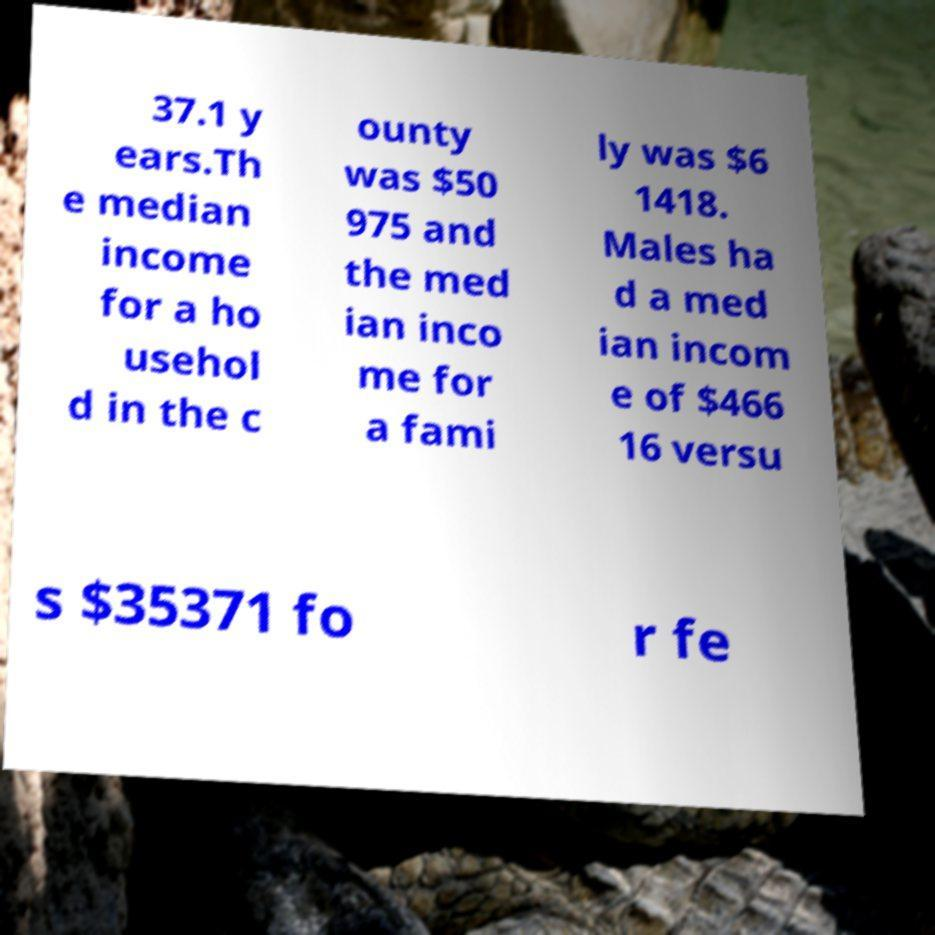What messages or text are displayed in this image? I need them in a readable, typed format. 37.1 y ears.Th e median income for a ho usehol d in the c ounty was $50 975 and the med ian inco me for a fami ly was $6 1418. Males ha d a med ian incom e of $466 16 versu s $35371 fo r fe 